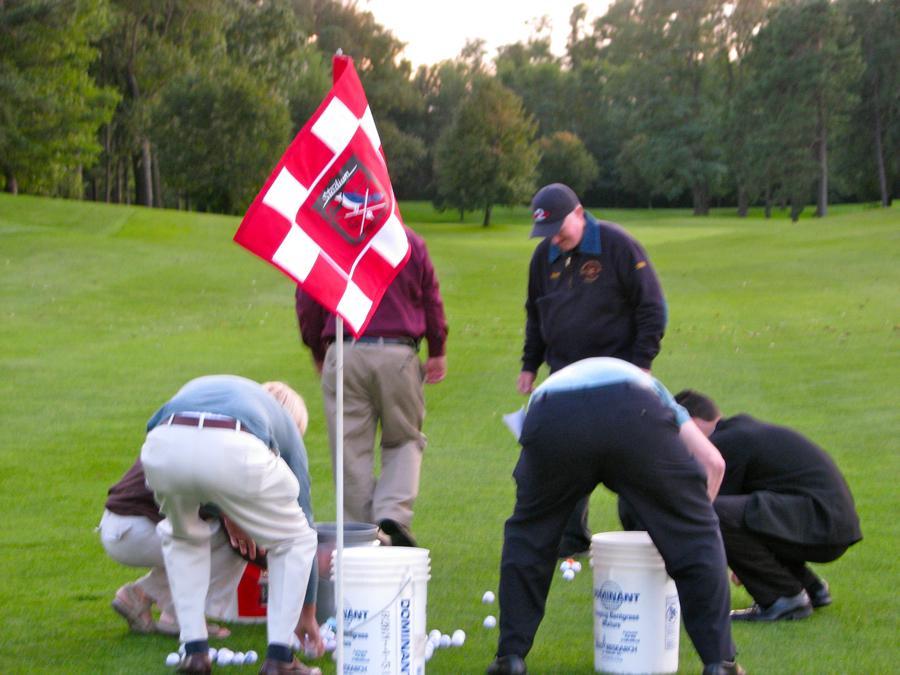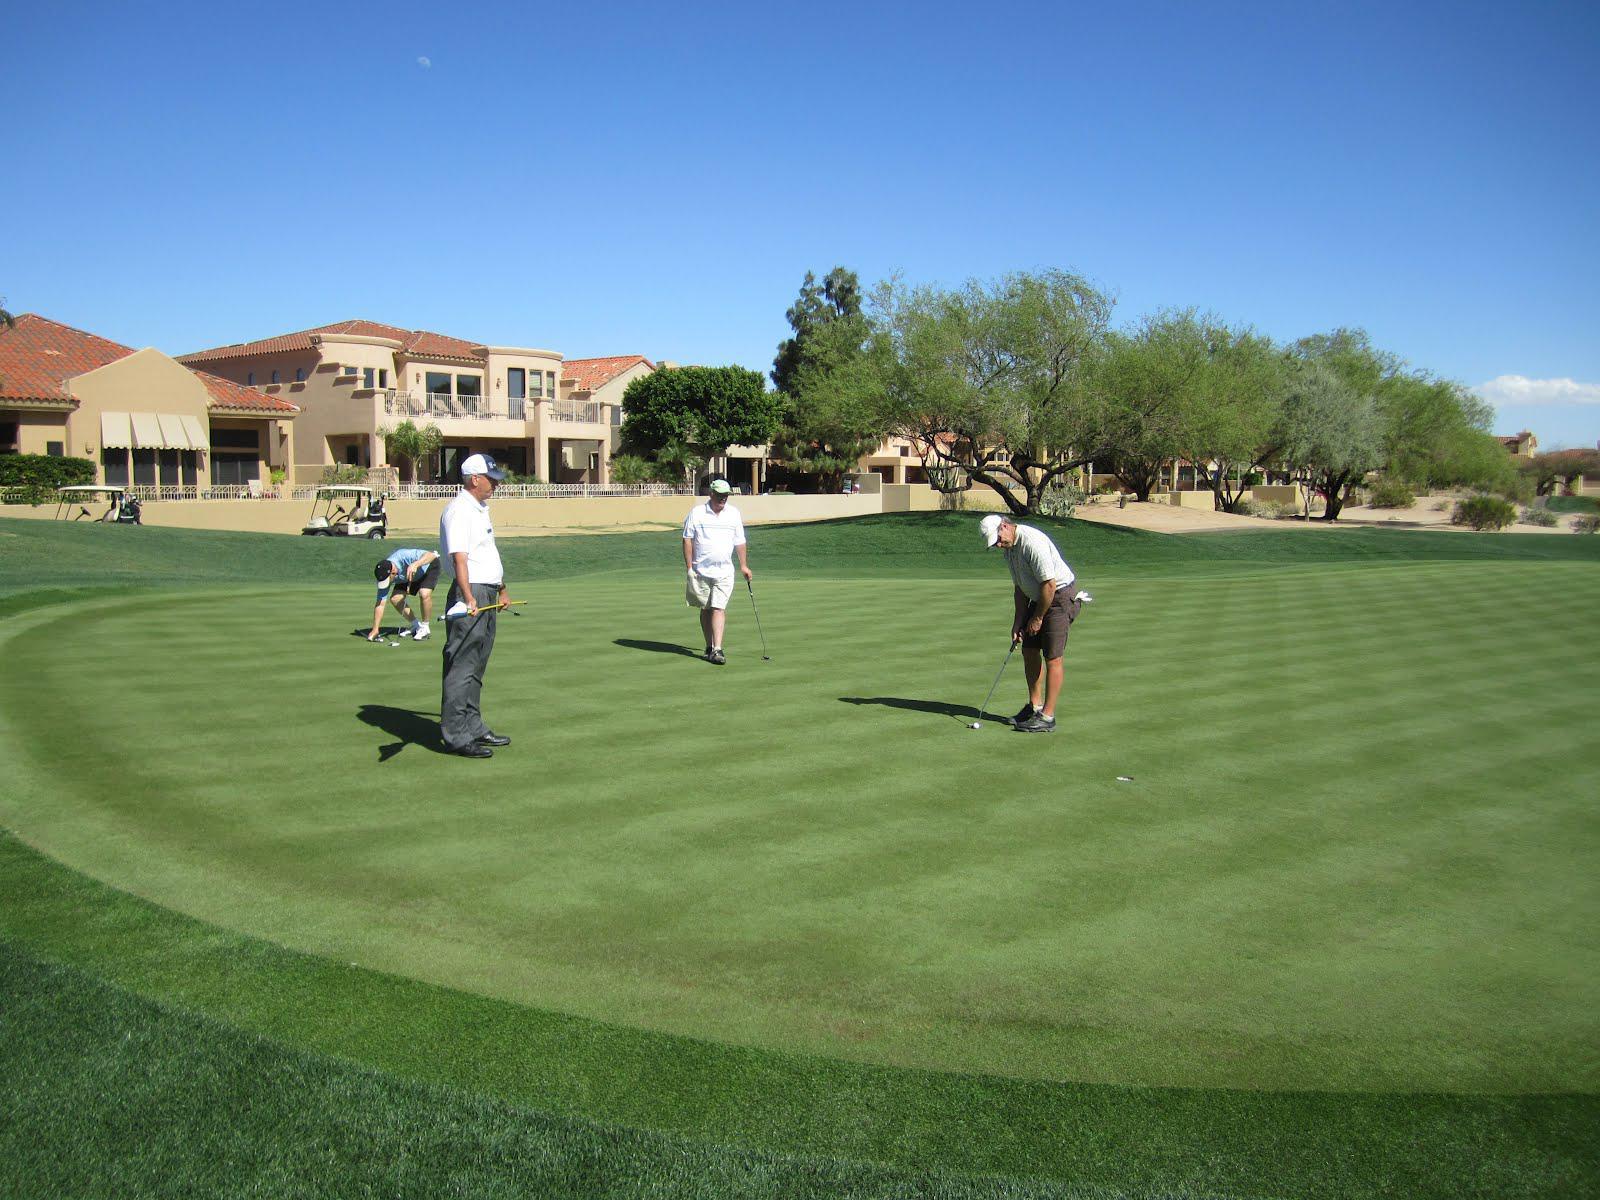The first image is the image on the left, the second image is the image on the right. For the images shown, is this caption "An image shows a group of people on a golf green with a red checkered flag on a pole." true? Answer yes or no. Yes. The first image is the image on the left, the second image is the image on the right. For the images displayed, is the sentence "A red and white checked flag sits on the golf course in one of the images." factually correct? Answer yes or no. Yes. 